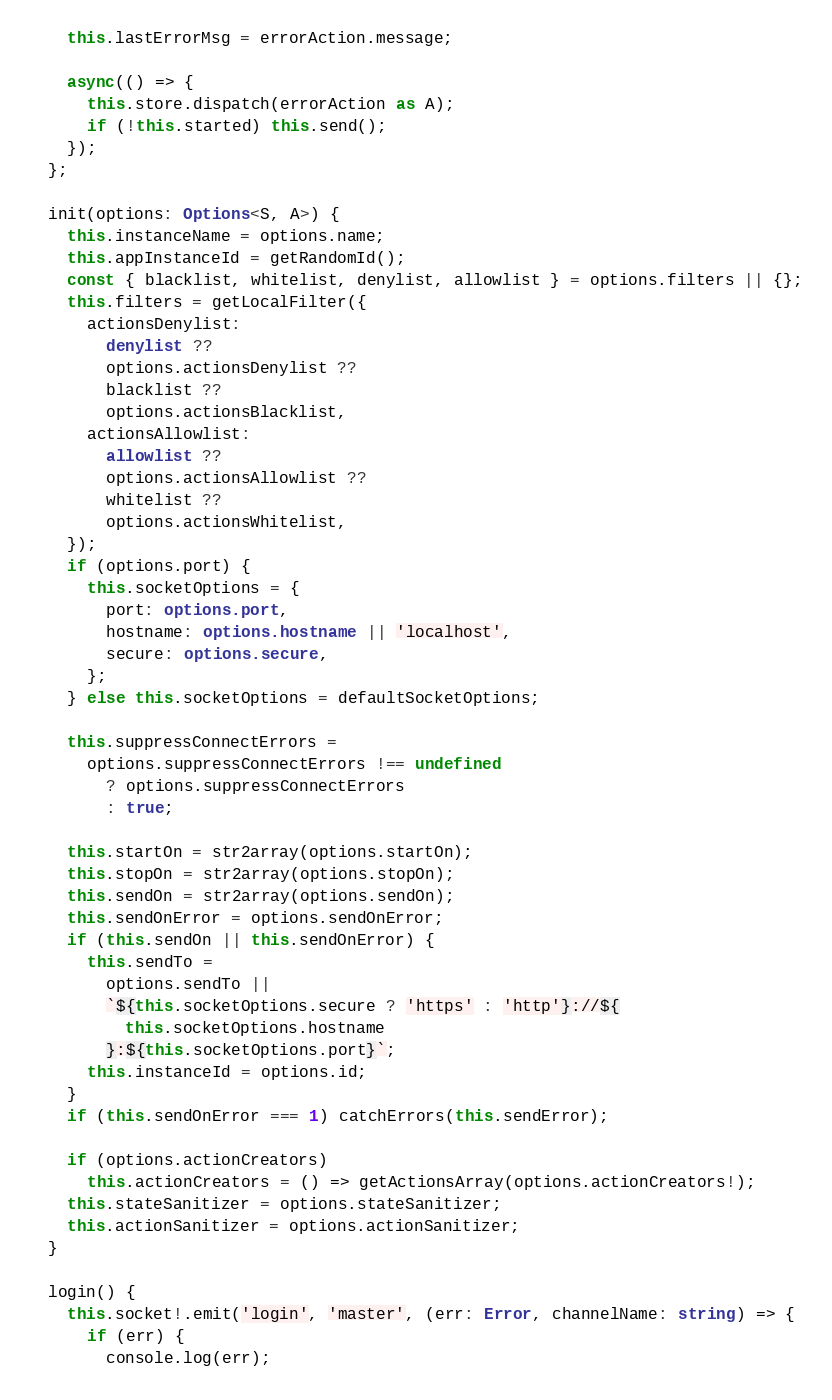<code> <loc_0><loc_0><loc_500><loc_500><_TypeScript_>    this.lastErrorMsg = errorAction.message;

    async(() => {
      this.store.dispatch(errorAction as A);
      if (!this.started) this.send();
    });
  };

  init(options: Options<S, A>) {
    this.instanceName = options.name;
    this.appInstanceId = getRandomId();
    const { blacklist, whitelist, denylist, allowlist } = options.filters || {};
    this.filters = getLocalFilter({
      actionsDenylist:
        denylist ??
        options.actionsDenylist ??
        blacklist ??
        options.actionsBlacklist,
      actionsAllowlist:
        allowlist ??
        options.actionsAllowlist ??
        whitelist ??
        options.actionsWhitelist,
    });
    if (options.port) {
      this.socketOptions = {
        port: options.port,
        hostname: options.hostname || 'localhost',
        secure: options.secure,
      };
    } else this.socketOptions = defaultSocketOptions;

    this.suppressConnectErrors =
      options.suppressConnectErrors !== undefined
        ? options.suppressConnectErrors
        : true;

    this.startOn = str2array(options.startOn);
    this.stopOn = str2array(options.stopOn);
    this.sendOn = str2array(options.sendOn);
    this.sendOnError = options.sendOnError;
    if (this.sendOn || this.sendOnError) {
      this.sendTo =
        options.sendTo ||
        `${this.socketOptions.secure ? 'https' : 'http'}://${
          this.socketOptions.hostname
        }:${this.socketOptions.port}`;
      this.instanceId = options.id;
    }
    if (this.sendOnError === 1) catchErrors(this.sendError);

    if (options.actionCreators)
      this.actionCreators = () => getActionsArray(options.actionCreators!);
    this.stateSanitizer = options.stateSanitizer;
    this.actionSanitizer = options.actionSanitizer;
  }

  login() {
    this.socket!.emit('login', 'master', (err: Error, channelName: string) => {
      if (err) {
        console.log(err);</code> 